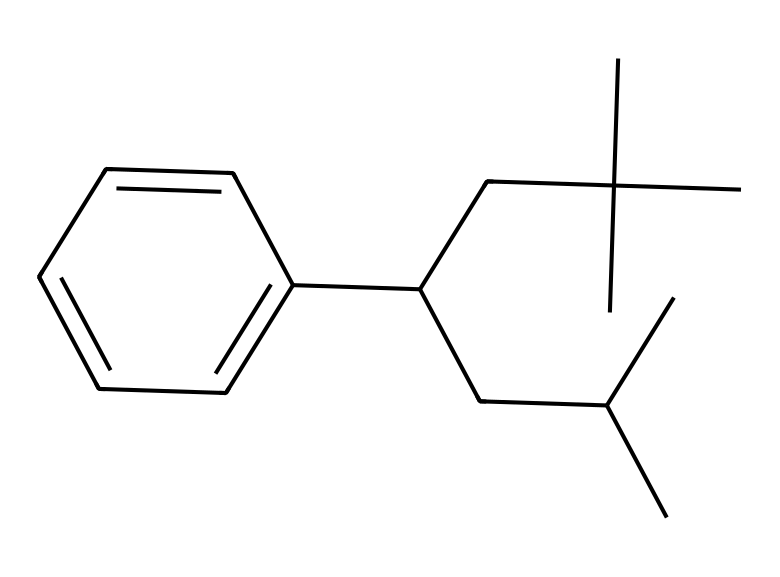What is the total number of carbon atoms in this structure? By analyzing the SMILES representation, we can count the 'C' characters, which represent carbon atoms. In this structure, there are 18 carbon atoms present in the chain and rings.
Answer: 18 What type of polymer is represented by this chemical? The structure is indicative of a polystyrene polymer, shown by the aromatic ring and the long carbon chain associated with polystyrene.
Answer: polystyrene How many double bonds are present in this molecule? In the given SMILES, the presence of a double bond can be identified by the '=' symbol. Scanning through the structure, we notice one double bond in the aromatic ring structure.
Answer: 1 What kind of functional group is primarily present in polystyrene? In the case of polystyrene, the primary functional group is an aromatic ring, identifiable from the benzene-like structure in the SMILES notation.
Answer: aromatic What is the significance of the branching in the carbon chains of polystyrene? The branching in the carbon chains affects the physical properties of the polymer, such as its density and thermal insulation properties, which are important for its applications in insulation materials.
Answer: affects physical properties How can the structure of this polymer affect its insulating properties? The long chain structure of polystyrene, along with its ability to form closed-cell structures, enhances its thermal resistance and insulating capabilities, making it suitable for modern insulation applications.
Answer: enhances thermal resistance 